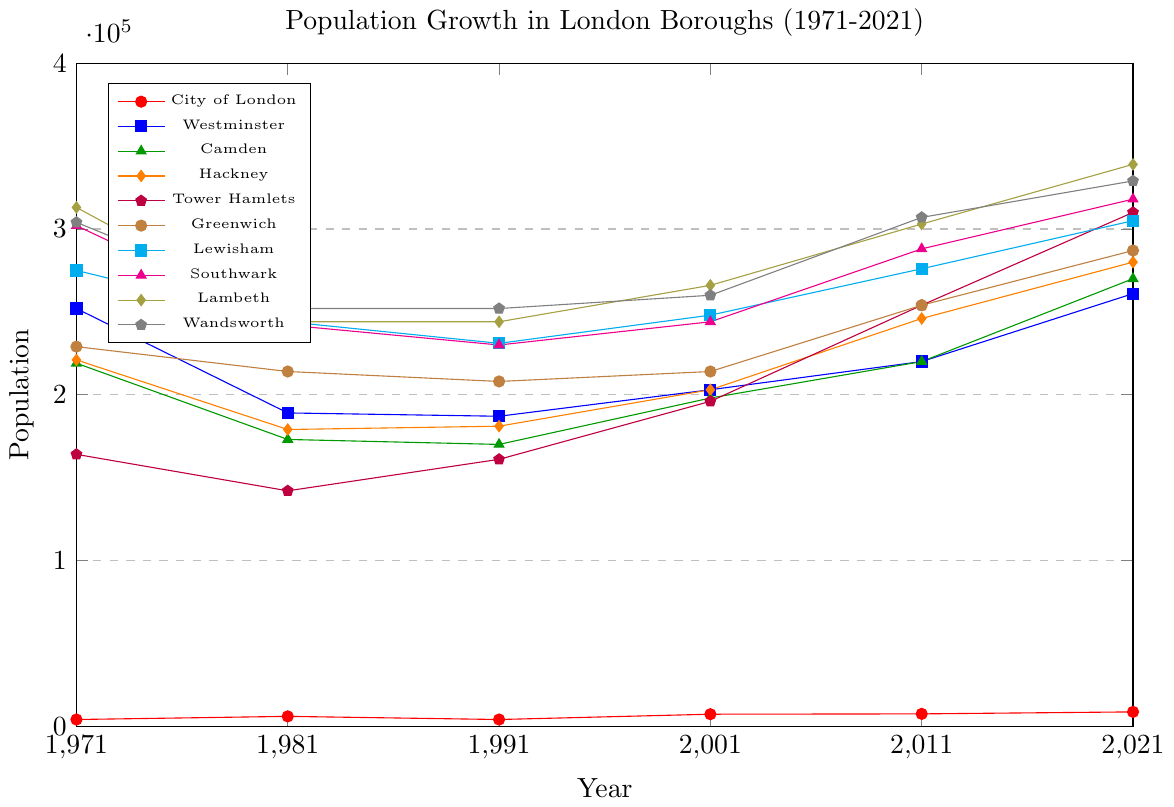Which borough had the highest population in 2021? To find the borough with the highest population in 2021, look for the highest point on the y-axis at the 2021 mark. Check the label that corresponds to the highest point.
Answer: Croydon Which borough had a lower population in 1981 compared to 1971? Compare the population values of each borough between 1971 and 1981. Identify the boroughs where the population decreased.
Answer: Westminster What is the average population of Lewisham from 1981 to 2021? Calculate the population of Lewisham for the years 1981, 1991, 2001, 2011, and 2021. Sum these values and divide by the number of years (5). (244000 + 231000 + 248000 + 276000 + 305000) / 5 = 1300000 / 5 = 260000.
Answer: 260000 Which borough had a greater increase in population from 2011 to 2021, Hackney or Tower Hamlets? Calculate the difference in population for Hackney and Tower Hamlets between 2011 and 2021. Hackney: 280000 - 246000 = 34000, Tower Hamlets: 310000 - 254000 = 56000. Compare the two differences.
Answer: Tower Hamlets Which borough had the lowest population in 1991? Identify the borough with the lowest point on the y-axis at the 1991 mark. Look at the label and corresponding value.
Answer: City of London How many boroughs had a population above 300,000 in 2021? Count the number of boroughs with populations greater than 300,000 at the 2021 mark.
Answer: 10 What is the total population of Southwark over the 50-year period? Sum the population values of Southwark from 1971, 1981, 1991, 2001, 2011, and 2021. (302000 + 242000 + 230000 + 244000 + 288000 + 318000) = 1624000.
Answer: 1624000 Did Wandsworth have a higher population in 1991 or in 2001? Compare the population values of Wandsworth in 1991 and 2001. 1991: 252000, 2001: 260000.
Answer: 2001 Which borough showed the most significant population growth between 1971 and 2021? Calculate the difference in population for each borough between 1971 and 2021. Identify the borough with the largest positive difference.
Answer: Croydon 